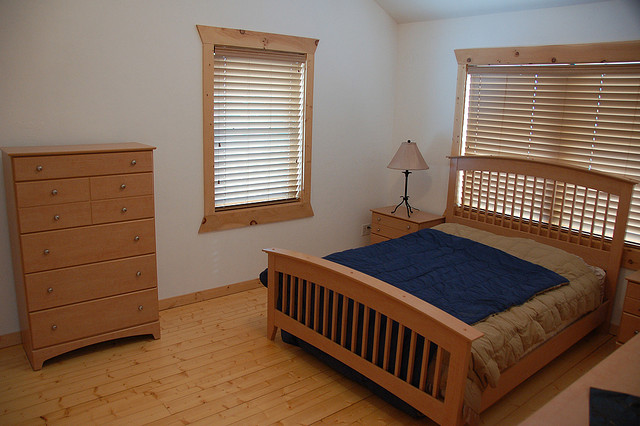<image>What is the source of heat? It is ambiguous what the source of heat is. It could be sunlight, a heater, oil, or an electric source. What is the source of heat? It is ambiguous what the source of heat is. It may be sunlight, heater, oil, or electric. 